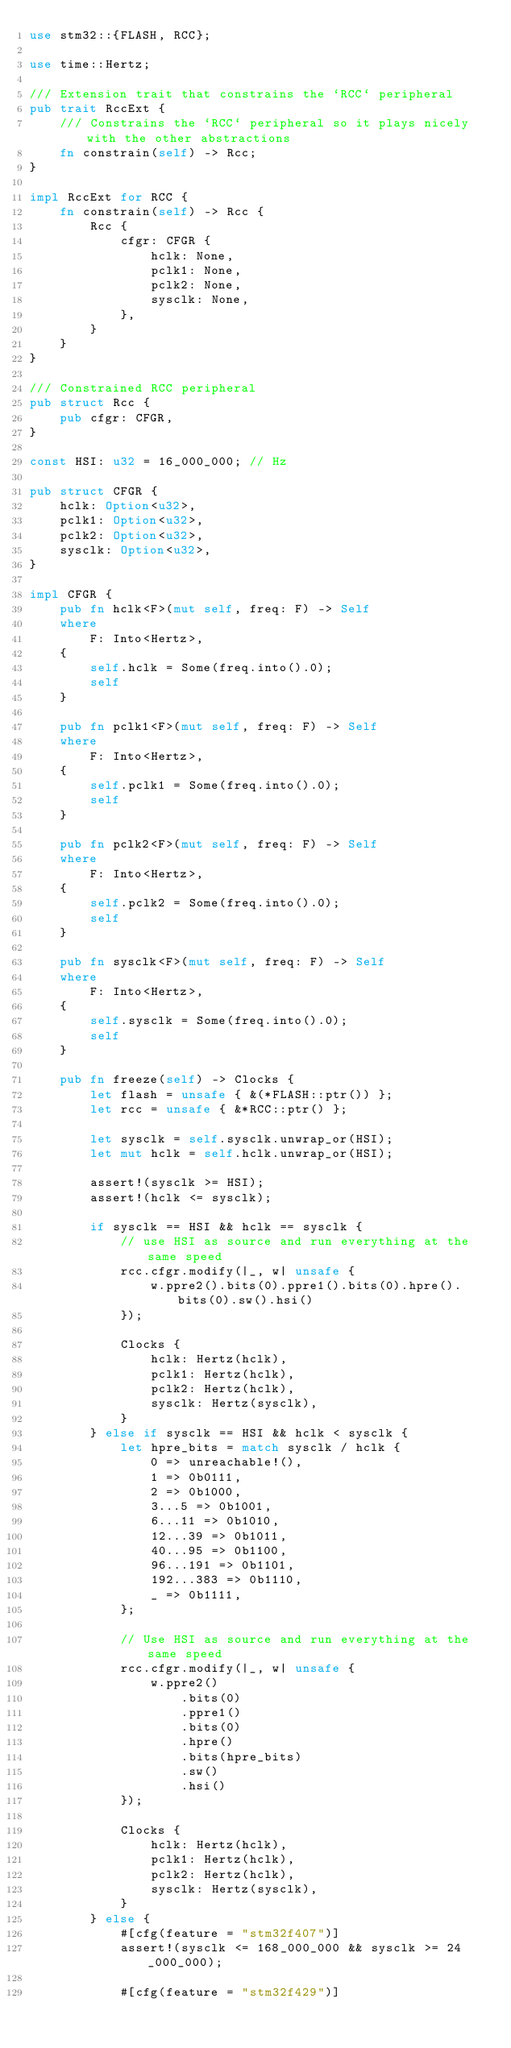<code> <loc_0><loc_0><loc_500><loc_500><_Rust_>use stm32::{FLASH, RCC};

use time::Hertz;

/// Extension trait that constrains the `RCC` peripheral
pub trait RccExt {
    /// Constrains the `RCC` peripheral so it plays nicely with the other abstractions
    fn constrain(self) -> Rcc;
}

impl RccExt for RCC {
    fn constrain(self) -> Rcc {
        Rcc {
            cfgr: CFGR {
                hclk: None,
                pclk1: None,
                pclk2: None,
                sysclk: None,
            },
        }
    }
}

/// Constrained RCC peripheral
pub struct Rcc {
    pub cfgr: CFGR,
}

const HSI: u32 = 16_000_000; // Hz

pub struct CFGR {
    hclk: Option<u32>,
    pclk1: Option<u32>,
    pclk2: Option<u32>,
    sysclk: Option<u32>,
}

impl CFGR {
    pub fn hclk<F>(mut self, freq: F) -> Self
    where
        F: Into<Hertz>,
    {
        self.hclk = Some(freq.into().0);
        self
    }

    pub fn pclk1<F>(mut self, freq: F) -> Self
    where
        F: Into<Hertz>,
    {
        self.pclk1 = Some(freq.into().0);
        self
    }

    pub fn pclk2<F>(mut self, freq: F) -> Self
    where
        F: Into<Hertz>,
    {
        self.pclk2 = Some(freq.into().0);
        self
    }

    pub fn sysclk<F>(mut self, freq: F) -> Self
    where
        F: Into<Hertz>,
    {
        self.sysclk = Some(freq.into().0);
        self
    }

    pub fn freeze(self) -> Clocks {
        let flash = unsafe { &(*FLASH::ptr()) };
        let rcc = unsafe { &*RCC::ptr() };

        let sysclk = self.sysclk.unwrap_or(HSI);
        let mut hclk = self.hclk.unwrap_or(HSI);

        assert!(sysclk >= HSI);
        assert!(hclk <= sysclk);

        if sysclk == HSI && hclk == sysclk {
            // use HSI as source and run everything at the same speed
            rcc.cfgr.modify(|_, w| unsafe {
                w.ppre2().bits(0).ppre1().bits(0).hpre().bits(0).sw().hsi()
            });

            Clocks {
                hclk: Hertz(hclk),
                pclk1: Hertz(hclk),
                pclk2: Hertz(hclk),
                sysclk: Hertz(sysclk),
            }
        } else if sysclk == HSI && hclk < sysclk {
            let hpre_bits = match sysclk / hclk {
                0 => unreachable!(),
                1 => 0b0111,
                2 => 0b1000,
                3...5 => 0b1001,
                6...11 => 0b1010,
                12...39 => 0b1011,
                40...95 => 0b1100,
                96...191 => 0b1101,
                192...383 => 0b1110,
                _ => 0b1111,
            };

            // Use HSI as source and run everything at the same speed
            rcc.cfgr.modify(|_, w| unsafe {
                w.ppre2()
                    .bits(0)
                    .ppre1()
                    .bits(0)
                    .hpre()
                    .bits(hpre_bits)
                    .sw()
                    .hsi()
            });

            Clocks {
                hclk: Hertz(hclk),
                pclk1: Hertz(hclk),
                pclk2: Hertz(hclk),
                sysclk: Hertz(sysclk),
            }
        } else {
            #[cfg(feature = "stm32f407")]
            assert!(sysclk <= 168_000_000 && sysclk >= 24_000_000);

            #[cfg(feature = "stm32f429")]</code> 